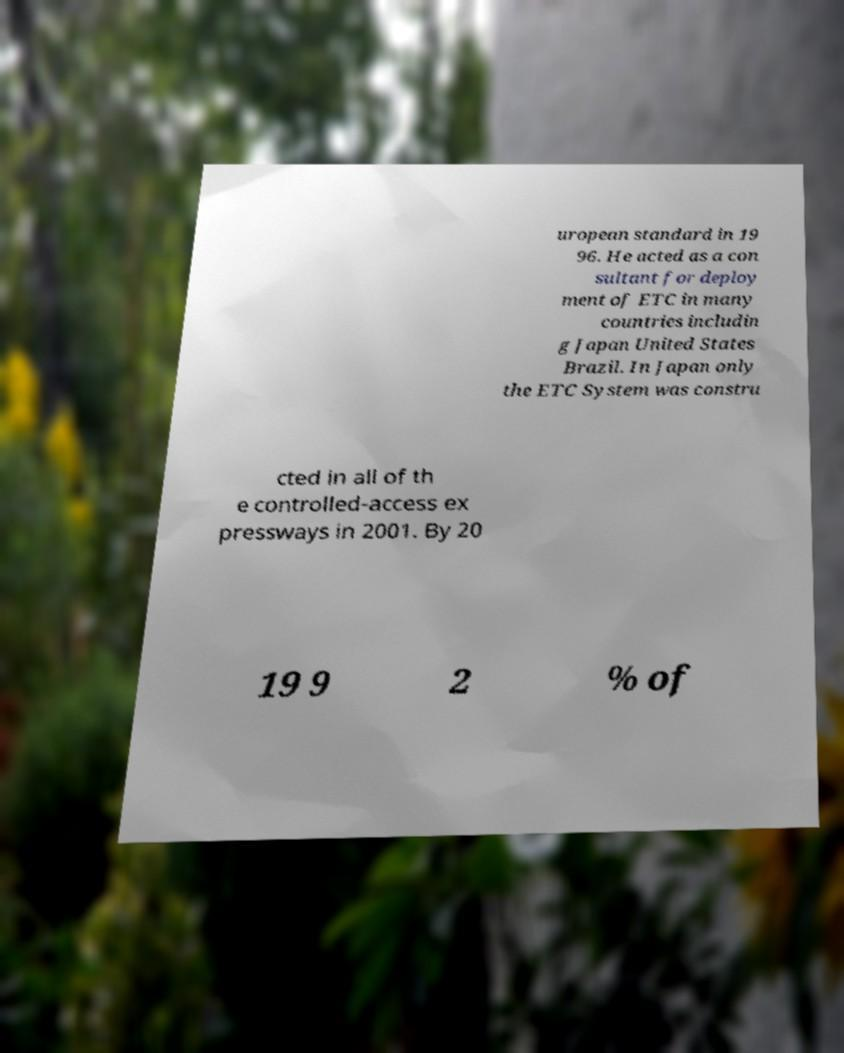There's text embedded in this image that I need extracted. Can you transcribe it verbatim? uropean standard in 19 96. He acted as a con sultant for deploy ment of ETC in many countries includin g Japan United States Brazil. In Japan only the ETC System was constru cted in all of th e controlled-access ex pressways in 2001. By 20 19 9 2 % of 